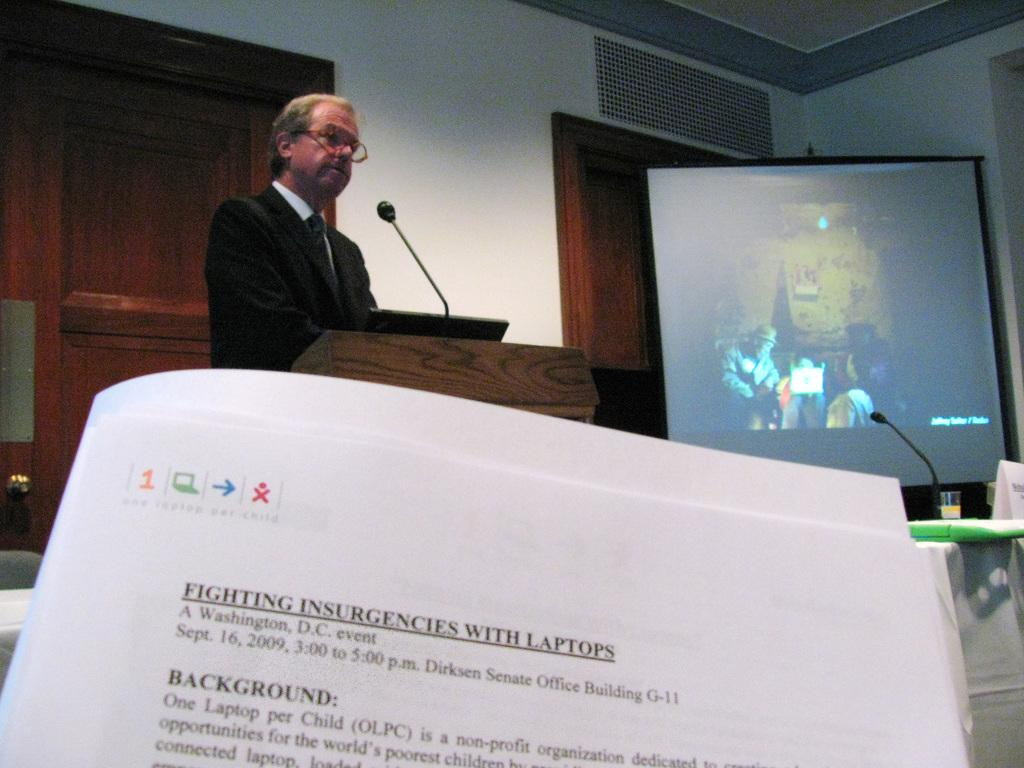Provide a one-sentence caption for the provided image. Somebody is presiding over a lecture, you can see a syllabus with the title Fighting insurgencies with laptops. 